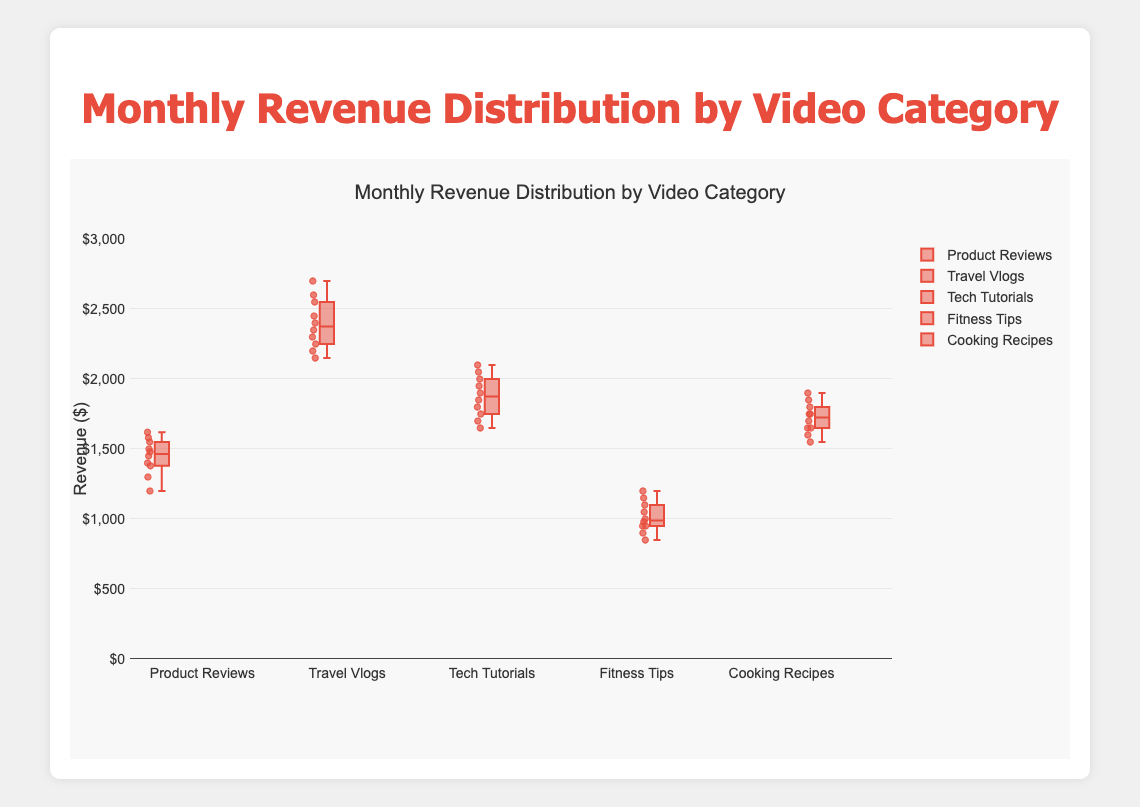What is the title of the figure? The title is displayed at the top of the figure. It reads 'Monthly Revenue Distribution by Video Category'.
Answer: Monthly Revenue Distribution by Video Category How many video categories are presented in the plot? The figure shows five different colors, and each box represents a different video category.
Answer: 5 Which video category has the highest median monthly revenue? The median is indicated by the central line in each box plot. 'Travel Vlogs' has the highest central line.
Answer: Travel Vlogs What is the median monthly revenue for Tech Tutorials? The median value of a box plot is the middle line within the box. For Tech Tutorials, it is around 1900.
Answer: 1900 Which video category has the lowest maximum monthly revenue? The maximum monthly revenue is indicated by the top whisker of each box. 'Fitness Tips' has the lowest top whisker.
Answer: Fitness Tips What is the interquartile range (IQR) for Cooking Recipes? The IQR is the range between the 25th and 75th percentiles, represented by the top and bottom of the box. For Cooking Recipes, it's between 1600 and 1800.
Answer: 200 Which category has the largest range of monthly revenue? The range is the difference between the maximum and minimum points (whiskers). 'Travel Vlogs' shows the largest distance from top to bottom whiskers.
Answer: Travel Vlogs Compare the median monthly revenue of Product Reviews and Fitness Tips. Which is higher and by how much? The median is the middle line of each box plot. Product Reviews' median is higher than Fitness Tips. Difference: 1500 (Product Reviews) - 975 (Fitness Tips) = 525.
Answer: Product Reviews by 525 What is the approximate range of revenue for Tech Tutorials? The range is the difference between the highest and lowest whiskers. For Tech Tutorials, it's from approximately 1650 to 2100.
Answer: 450 What can be said about the variability of revenues in Fitness Tips compared to Cooking Recipes? Variability is shown by the height of the box and whiskers. Fitness Tips' box and whiskers are shorter, indicating less variability compared to Cooking Recipes.
Answer: Less variable 